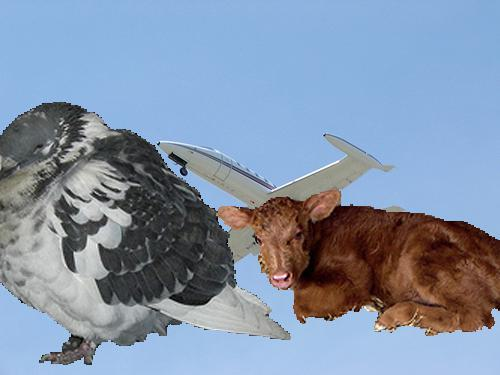What is unusual about the bird in this image? The bird is portrayed with the body of an aeroplane, blending biological and mechanical elements in an imaginative depiction. 